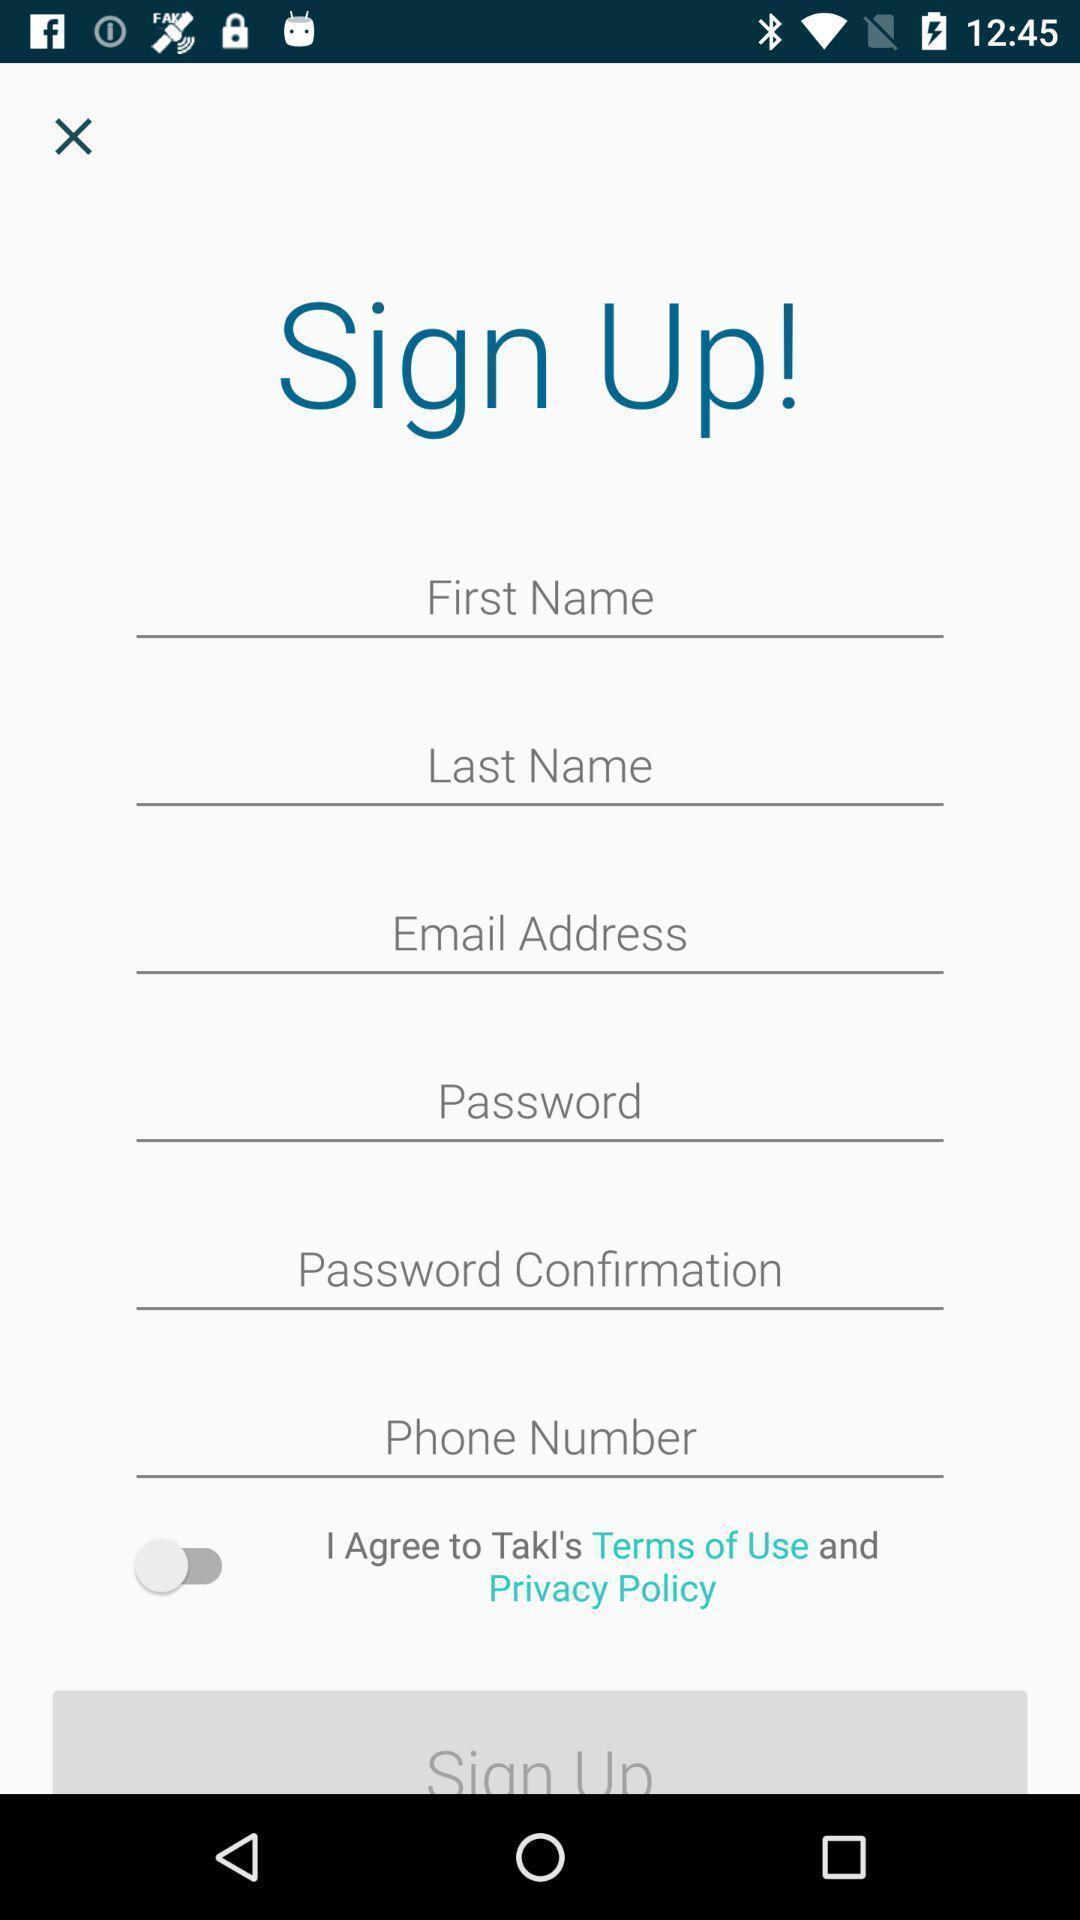What can you discern from this picture? Sing up page. 